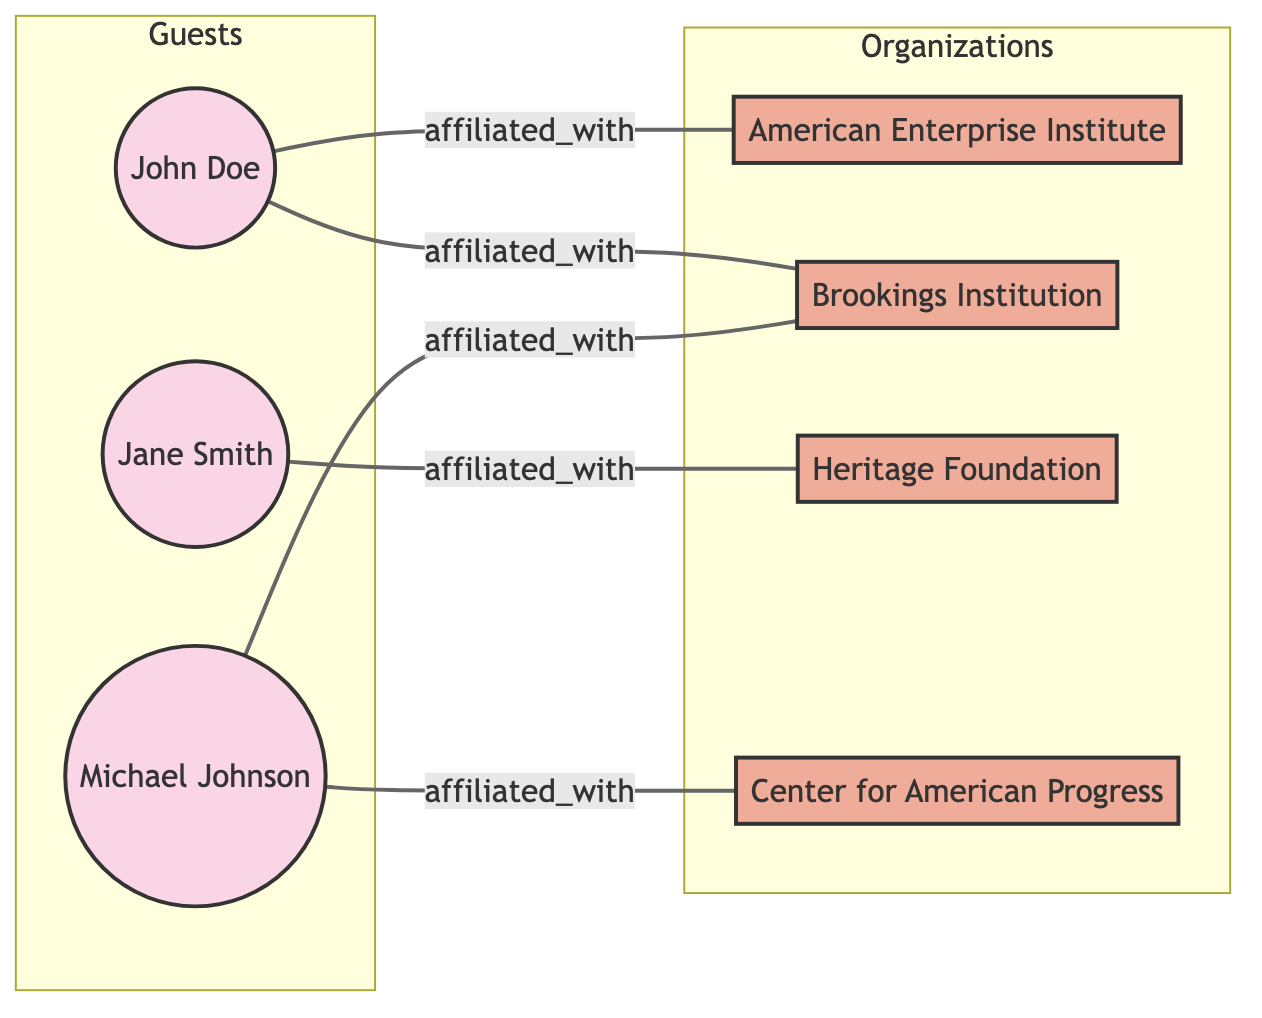What are the names of the guests featured in this network? The diagram displays three nodes representing guests: John Doe, Jane Smith, and Michael Johnson. These are easily identifiable as they are labeled as guests in the node definitions.
Answer: John Doe, Jane Smith, Michael Johnson How many organizations are represented in the diagram? The diagram contains four nodes that represent organizations: American Enterprise Institute, Brookings Institution, Heritage Foundation, and Center for American Progress. A count can be taken from these nodes.
Answer: 4 Who is affiliated with the Brookings Institution? In the diagram, two guests are connected to the Brookings Institution: John Doe and Michael Johnson. The edges labeled "affiliated_with" show the relationships clearly.
Answer: John Doe, Michael Johnson Which organization is Jane Smith affiliated with? The edge connected to Jane Smith indicates her affiliation with the Heritage Foundation. This connection can be traced directly on the diagram.
Answer: Heritage Foundation Which guest has affiliations with the most organizations? By examining the connections, it is clear that John Doe is affiliated with two organizations: American Enterprise Institute and Brookings Institution. In contrast, the other guests have fewer affiliations.
Answer: John Doe What is the total number of edges in the diagram? There are five connections (edges) shown in the diagram representing affiliations. Counting these edges directly reveals that number.
Answer: 5 What is the type of the node that Michael Johnson is? The node for Michael Johnson is labeled as a guest, which can be confirmed by checking the node definitions specified in the diagram.
Answer: guest Are there any guests affiliated with the Center for American Progress? The diagram indicates that Michael Johnson is affiliated with the Center for American Progress, shown by the edge connecting him to this organization.
Answer: Yes Which guest is affiliated with the Heritage Foundation? The edge shows that Jane Smith has an affiliation with the Heritage Foundation, which can be directly seen from the diagram.
Answer: Jane Smith 